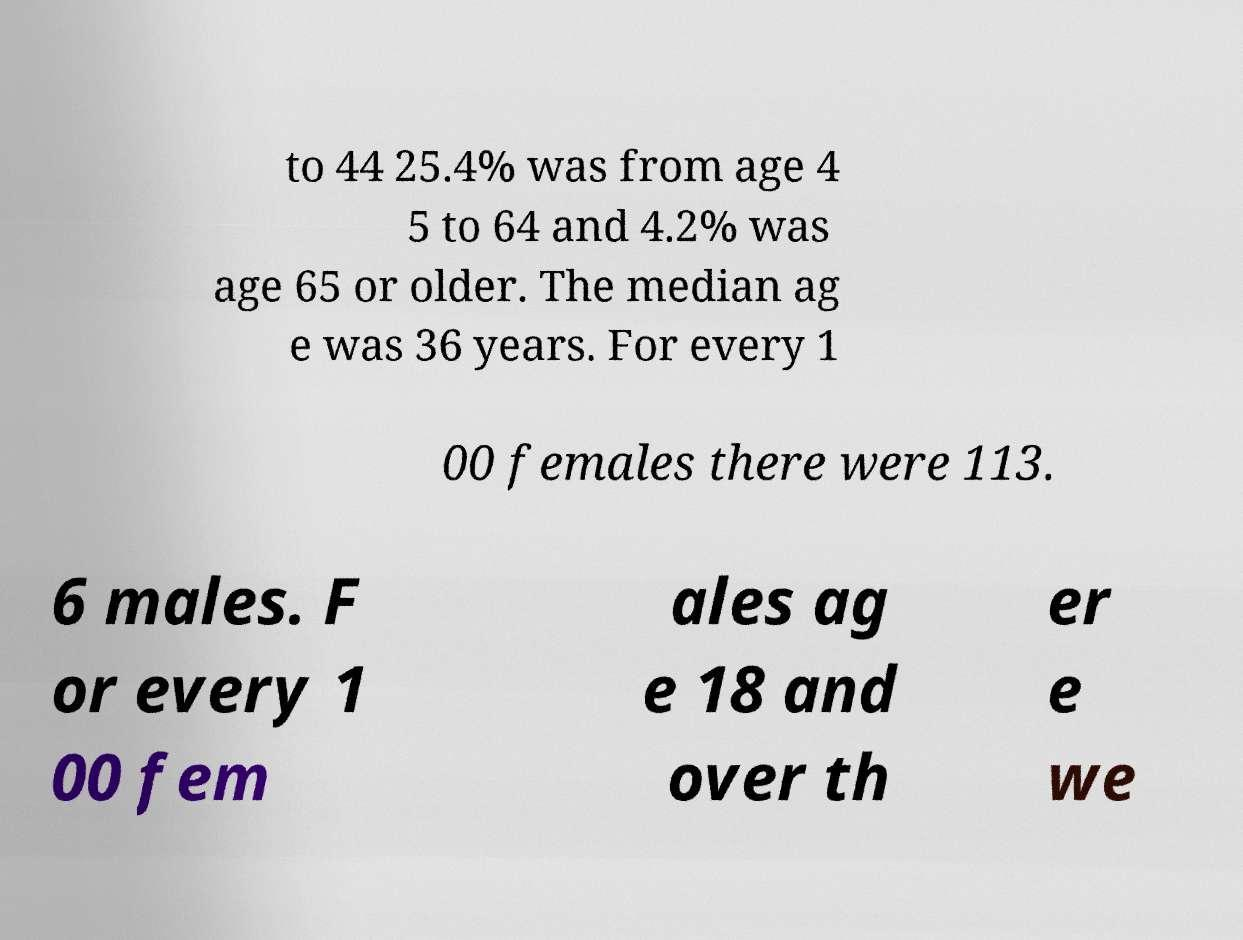Please identify and transcribe the text found in this image. to 44 25.4% was from age 4 5 to 64 and 4.2% was age 65 or older. The median ag e was 36 years. For every 1 00 females there were 113. 6 males. F or every 1 00 fem ales ag e 18 and over th er e we 